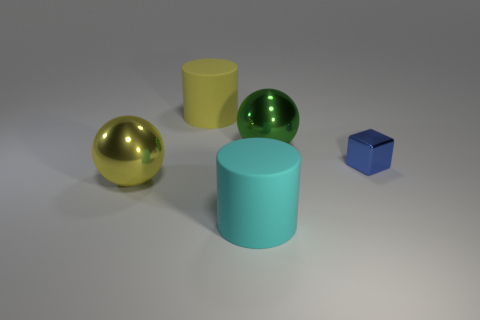Is there a green metallic ball of the same size as the yellow matte cylinder?
Your response must be concise. Yes. How many other matte objects have the same shape as the cyan object?
Make the answer very short. 1. Are there an equal number of tiny shiny objects that are in front of the shiny block and big cylinders behind the cyan thing?
Offer a terse response. No. Are any large cyan matte cylinders visible?
Provide a succinct answer. Yes. There is a yellow object in front of the large sphere that is right of the large matte cylinder that is behind the tiny blue metal object; what is its size?
Give a very brief answer. Large. The other yellow thing that is the same size as the yellow rubber thing is what shape?
Your answer should be very brief. Sphere. How many objects are either big yellow objects that are in front of the big yellow rubber object or large yellow things?
Provide a short and direct response. 2. Is there a cube that is behind the rubber object that is in front of the metallic object that is on the left side of the large cyan cylinder?
Offer a terse response. Yes. What number of large yellow objects are there?
Your answer should be very brief. 2. What number of objects are either big cylinders left of the large cyan cylinder or metallic things that are to the right of the yellow shiny sphere?
Provide a short and direct response. 3. 